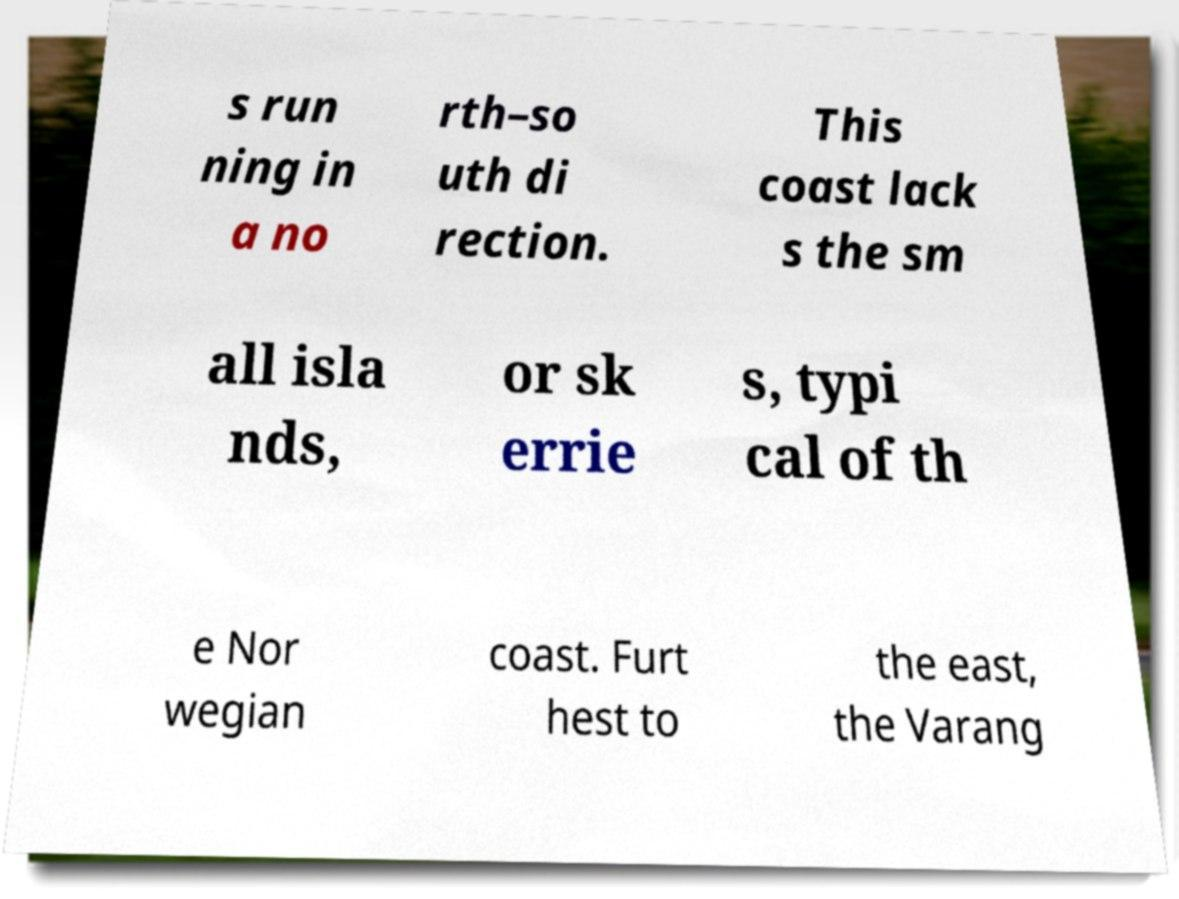I need the written content from this picture converted into text. Can you do that? s run ning in a no rth–so uth di rection. This coast lack s the sm all isla nds, or sk errie s, typi cal of th e Nor wegian coast. Furt hest to the east, the Varang 